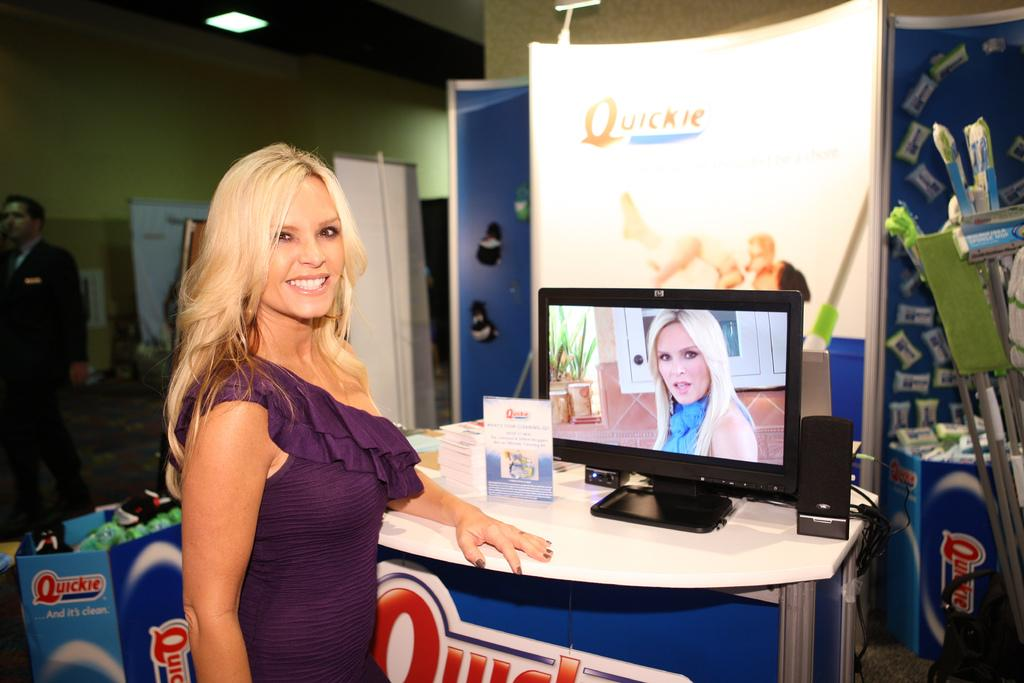<image>
Offer a succinct explanation of the picture presented. A blond woman standing in front of a stand which has the slogan Quickie on it 